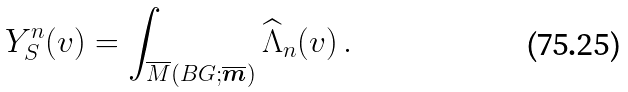<formula> <loc_0><loc_0><loc_500><loc_500>Y ^ { n } _ { S } ( v ) = \int _ { \overline { M } ( B G ; \overline { \boldsymbol m } ) } \widehat { \Lambda } _ { n } ( v ) \, .</formula> 